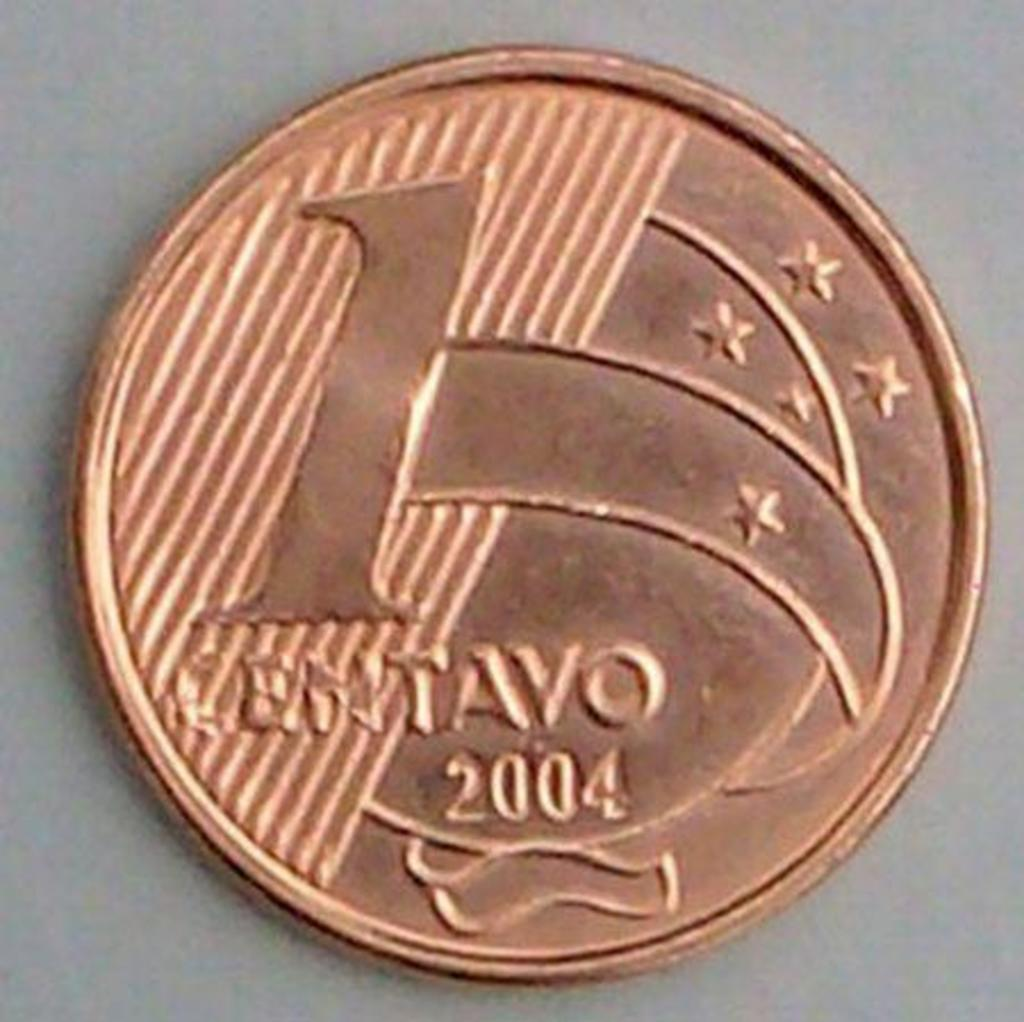Provide a one-sentence caption for the provided image. A bronze coin worth 1 cent is on a surface. 